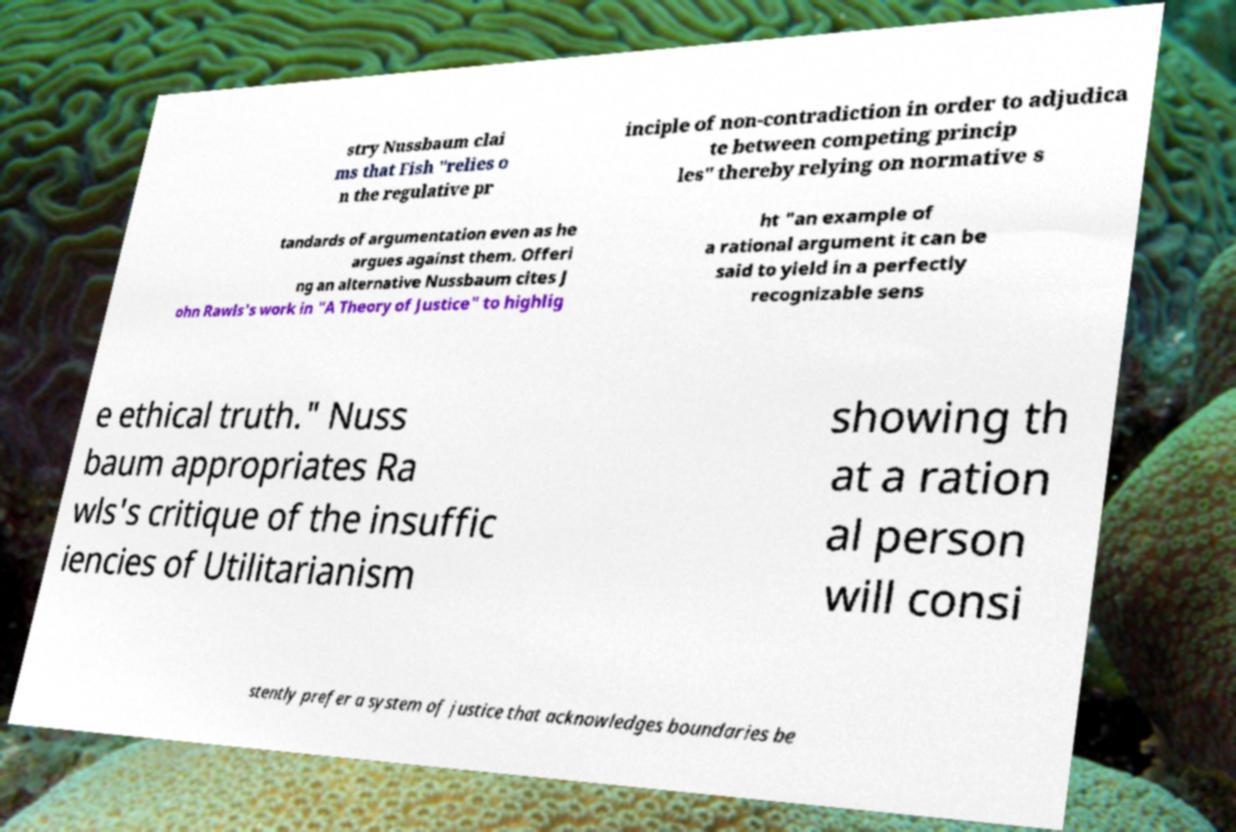Please identify and transcribe the text found in this image. stry Nussbaum clai ms that Fish "relies o n the regulative pr inciple of non-contradiction in order to adjudica te between competing princip les" thereby relying on normative s tandards of argumentation even as he argues against them. Offeri ng an alternative Nussbaum cites J ohn Rawls's work in "A Theory of Justice" to highlig ht "an example of a rational argument it can be said to yield in a perfectly recognizable sens e ethical truth." Nuss baum appropriates Ra wls's critique of the insuffic iencies of Utilitarianism showing th at a ration al person will consi stently prefer a system of justice that acknowledges boundaries be 